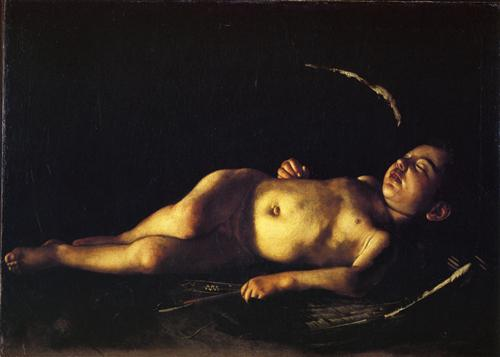If this image were part of a story, what do you think the plot would be about? The image could be part of a story that explores the quiet, reflective moments of a young boy's life. The plot might revolve around his daily experiences and the simple joys and peaceful moments he finds in his surroundings. It could delve into themes of innocence, tranquility, and the purity of childhood. Perhaps the boy lives in a rural setting, where he spends his days exploring nature, playing with friends, and discovering the world around him. The overall narrative might focus on the beauty of these moments, capturing the essence of a time in life when everything is new and wondrous. Describe a day in the life of the boy in the painting using vivid and imaginative language. As dawn's first light softly filters through the trees, the boy stirs from his peaceful slumber on the wooden bench. He awakens with a gentle stretch, his eyes twinkling with the promise of a new day. The air is crisp and filled with the sounds of morning birdsong, as he steps barefoot onto the dew-kissed grass. His journey begins with a playful chase of butterflies through wildflower meadows, their vibrant hues painting the landscape in splashes of color. The sun climbs higher, casting warm, golden rays that glisten like fairy dust. By midday, he finds himself at a clear, babbling brook, where he cools his feet in the refreshing waters, watching as the tiny fish dart to and fro.

Afternoon brings adventures among the towering trees of the nearby forest, where he imagines himself a brave explorer, discovering hidden treasures and secret paths. The scent of pine and earth fills his senses, as he climbs to the highest branch, feeling as though he can touch the sky. As the sun begins its descent, painting the sky in hues of orange and pink, he returns home, content and tired. He ends his day under the vast canopy of stars, lying back on the sharegpt4v/same wooden bench, his face illuminated by the soft glow of the moon. With a heart full of wonder and joy, he drifts back to sleep, cradled by the gentle embrace of night. 